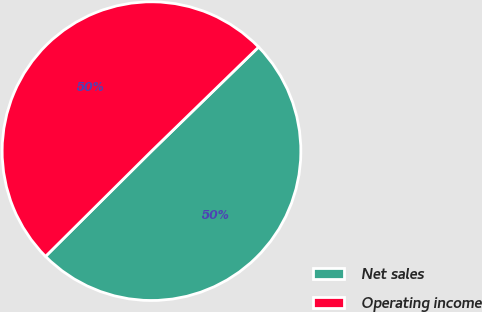Convert chart. <chart><loc_0><loc_0><loc_500><loc_500><pie_chart><fcel>Net sales<fcel>Operating income<nl><fcel>49.83%<fcel>50.17%<nl></chart> 